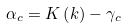Convert formula to latex. <formula><loc_0><loc_0><loc_500><loc_500>\alpha _ { c } = K \left ( k \right ) - \gamma _ { c }</formula> 